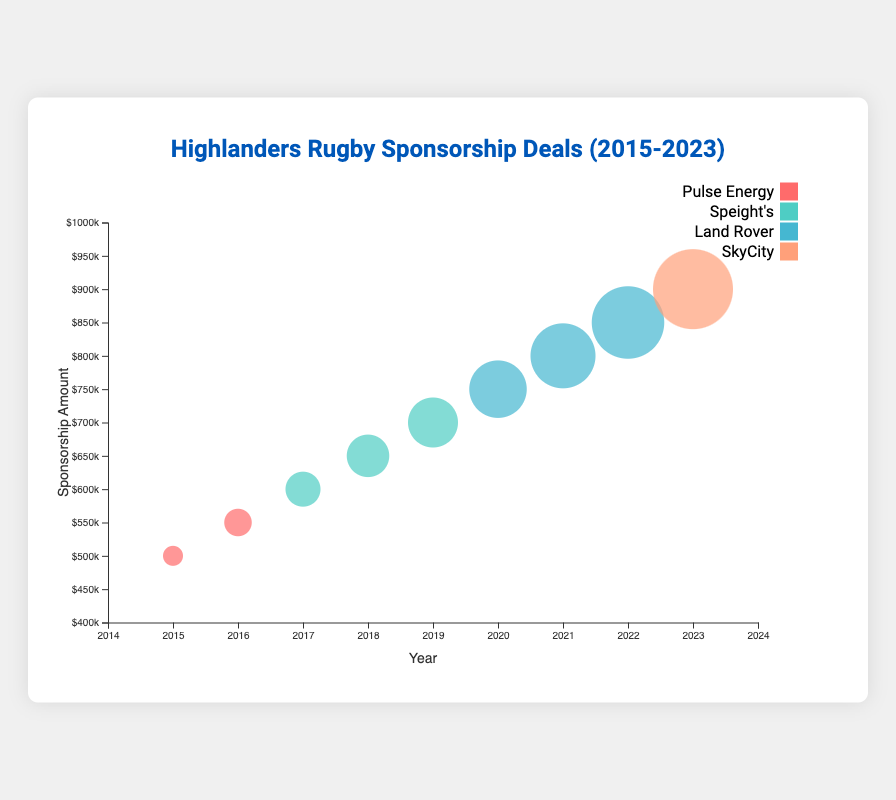What is the title of the chart? The title of the chart is shown prominently at the top, centered and in a larger font. The text reads "Highlanders Rugby Sponsorship Deals (2015-2023)".
Answer: Highlanders Rugby Sponsorship Deals (2015-2023) Which sponsor contributed the highest amount in any single year, and what was the amount? By looking at the color coding and the bubble size, SkyCity contributed the highest amount in 2023 with $900,000. The bubble representing 2023 is the largest and differently colored.
Answer: SkyCity, $900,000 How did the sponsorship amount from Land Rover change from 2020 to 2022? Refer to the bubbles representing Land Rover (distinct color) for the years 2020, 2021, and 2022. The amount increases from $750,000 (2020) to $800,000 (2021) to $850,000 (2022).
Answer: Increased from $750,000 to $850,000 How many different sponsors are there in total during the period 2015-2023? The legend in the chart lists all the unique sponsors with corresponding colors: Pulse Energy, Speight's, Land Rover, and SkyCity. There are 4 sponsors in total.
Answer: 4 Which year had the lowest sponsorship amount, and what was the amount? By comparing the smallest circles, the smallest one represents the year 2015, associated with Pulse Energy, and the amount is $500,000.
Answer: 2015, $500,000 What is the overall trend in sponsorship amounts over the years? By observing the bubble sizes and the general pattern, the sponsorship amounts have increased over time from $500,000 in 2015 to $900,000 in 2023. This indicates an upward trend.
Answer: Upward trend Compare the contributions of Speight's in 2017 and 2019. Which year has a higher amount and by how much? Check the bubbles with Speight's color for 2017 and 2019. The amounts are $600,000 in 2017 and $700,000 in 2019. 2019 has a higher amount by the difference between $700,000 and $600,000.
Answer: 2019, $100,000 higher What is the average amount contributed by all sponsors in 2020? In 2020, only Land Rover had a contribution of $750,000, so the average amount for that year is just the single amount itself.
Answer: $750,000 What is the most prominent feature of the bubble chart that makes it different from a bar chart? The bubble chart uses bubble sizes to represent the amount of sponsorships, highlighting both the year and sponsor with different colors, allowing for multiple dimensions of data to be visualized at once.
Answer: Bubble sizes Which sponsor had the longest continuous sponsorship period, and what was the duration? By checking the sequential years each sponsor appears, Speight's is visible from 2017 to 2019, lasting 3 years without interruption.
Answer: Speight's, 3 years 